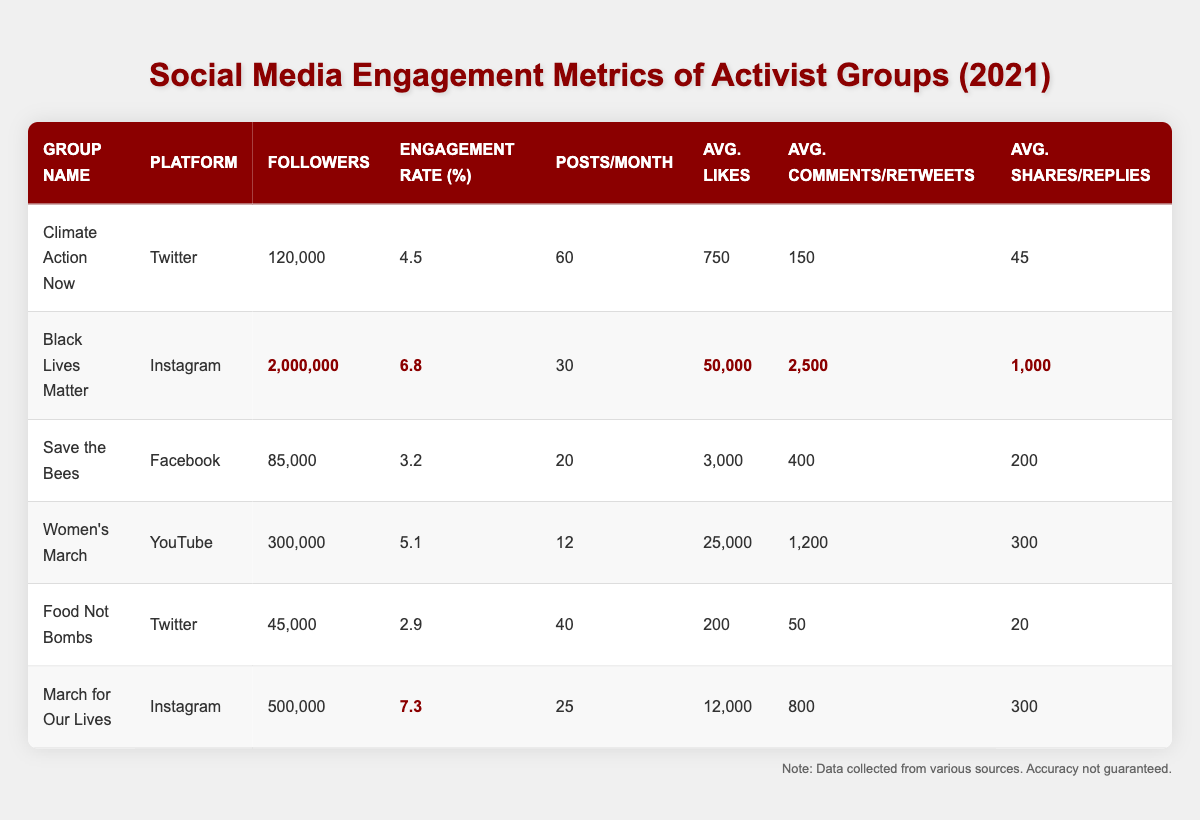What is the engagement rate of March for Our Lives? The table shows that the engagement rate for March for Our Lives is highlighted, indicating it as a key metric. From the table, I can see that it is **7.3**.
Answer: 7.3 Which activist group has the highest number of followers? By comparing the "Followers" column, I observe that Black Lives Matter has the highest number with **2,000,000** followers.
Answer: 2,000,000 How many total posts did Climate Action Now make in 2021? Climate Action Now posts **60** times per month. For the whole year (12 months), I multiply 60 by 12, which gives 720 posts in total.
Answer: 720 What is the average engagement rate for all activist groups listed? The engagement rates are 4.5, 6.8, 3.2, 5.1, 2.9, and 7.3. I sum these values to get **30.8** and then divide by 6 (the number of groups) to find the average: 30.8 / 6 = 5.13.
Answer: 5.13 Does Save the Bees have more followers than Food Not Bombs? Looking at the table, Save the Bees has **85,000** followers while Food Not Bombs has **45,000** followers. Since 85,000 is greater than 45,000, the answer is yes.
Answer: Yes What is the difference in average likes between Black Lives Matter and March for Our Lives? The average likes for Black Lives Matter are **50,000** and for March for Our Lives, it is **12,000**. To find the difference, I subtract 12,000 from 50,000, which gives **38,000**.
Answer: 38,000 Who has a higher engagement rate: Food Not Bombs or Save the Bees? Food Not Bombs' engagement rate is **2.9**, whereas Save the Bees has **3.2**. Since 3.2 is greater than 2.9, this indicates that Save the Bees has a higher engagement rate.
Answer: Save the Bees What is the total average of shares/replies for all activist groups? The shares/replies for each group are: 45 (Climate Action Now), 1000 (Black Lives Matter), 200 (Save the Bees), 300 (Women's March), 20 (Food Not Bombs), and 300 (March for Our Lives). Adding these together gives **1865**. To find the average, I divide by 6, resulting in an average of approximately **310.83**.
Answer: 310.83 Which platform had the highest average likes per post? Observing the average likes, Black Lives Matter with **50,000**, is significantly higher than any other platform. The next nearest is Women's March with **25,000**. Therefore, Instagram is the platform with the highest average likes per post.
Answer: Instagram 